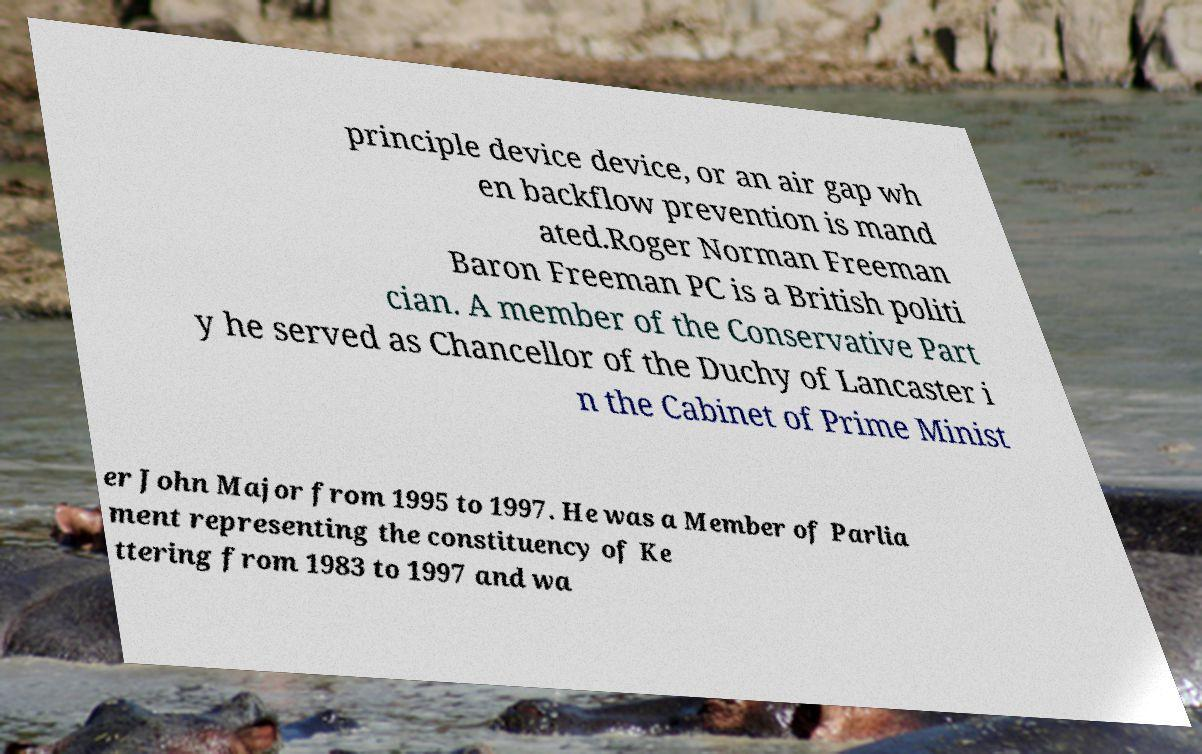Could you assist in decoding the text presented in this image and type it out clearly? principle device device, or an air gap wh en backflow prevention is mand ated.Roger Norman Freeman Baron Freeman PC is a British politi cian. A member of the Conservative Part y he served as Chancellor of the Duchy of Lancaster i n the Cabinet of Prime Minist er John Major from 1995 to 1997. He was a Member of Parlia ment representing the constituency of Ke ttering from 1983 to 1997 and wa 